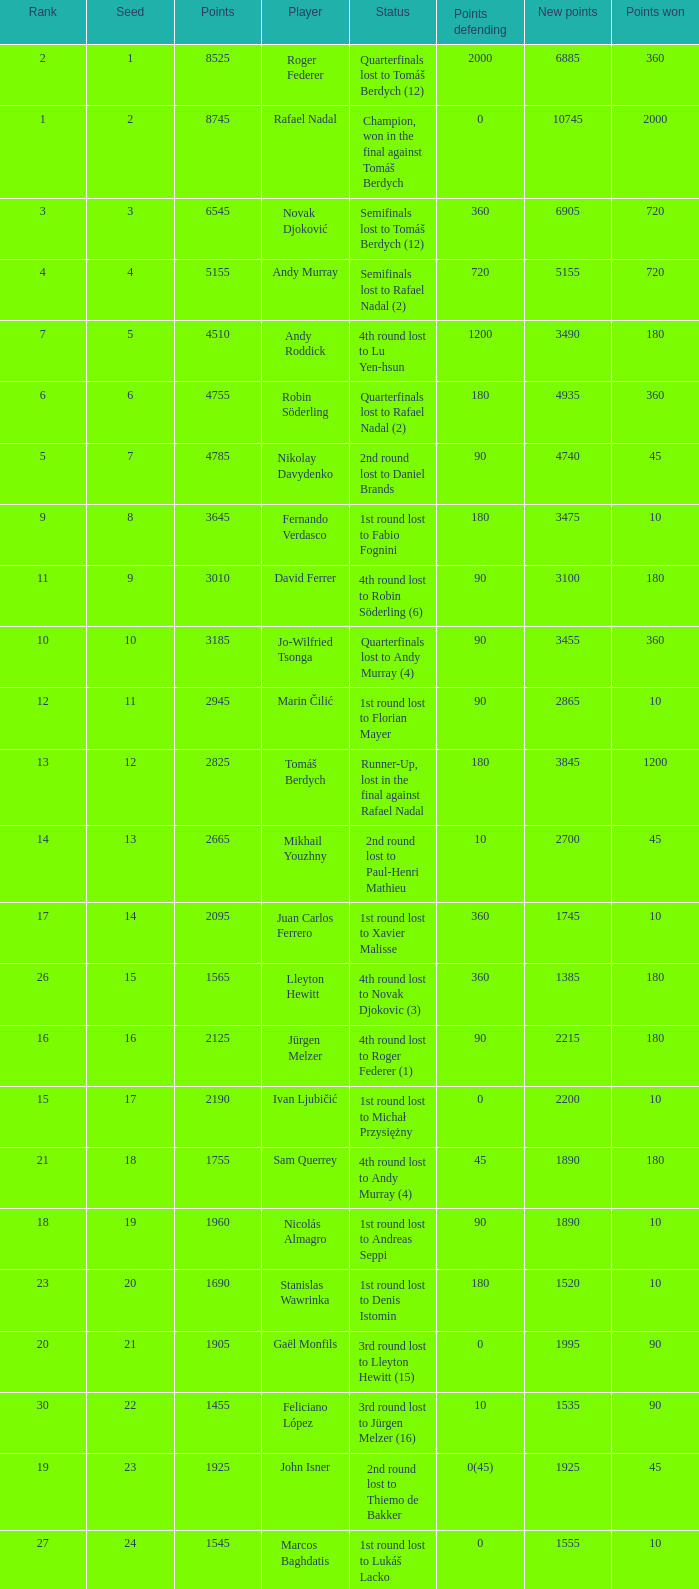Name the least new points for points defending is 1200 3490.0. 